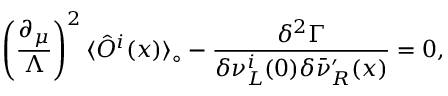Convert formula to latex. <formula><loc_0><loc_0><loc_500><loc_500>\left ( { \frac { \partial _ { \mu } } { \Lambda } } \right ) ^ { 2 } \langle \hat { O } ^ { i } ( x ) \rangle _ { \circ } - { \frac { \delta ^ { 2 } \Gamma } { \delta \nu _ { L } ^ { i } ( 0 ) \delta \bar { \nu } _ { R } ^ { \prime } ( x ) } } = 0 ,</formula> 